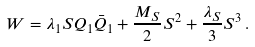Convert formula to latex. <formula><loc_0><loc_0><loc_500><loc_500>W = \lambda _ { 1 } S Q _ { 1 } \bar { Q } _ { 1 } + \frac { M _ { S } } { 2 } S ^ { 2 } + \frac { \lambda _ { S } } { 3 } S ^ { 3 } \, .</formula> 